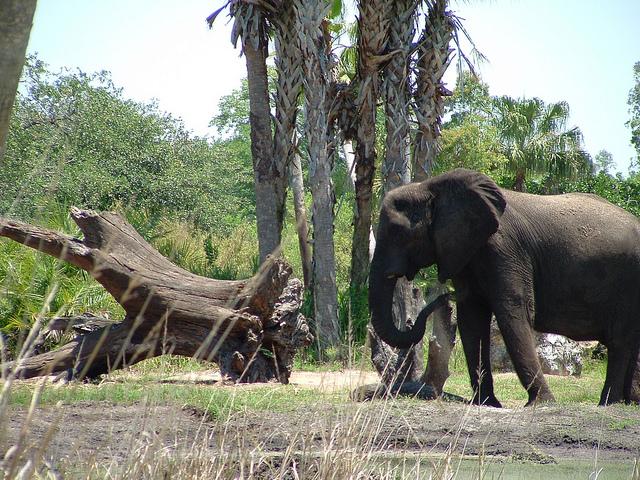How many elephants are near the log?
Answer briefly. 1. Does  it have leaves?
Quick response, please. Yes. Does this animal have a strong nose?
Quick response, please. Yes. How many trees are laying on the ground?
Short answer required. 1. 